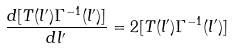Convert formula to latex. <formula><loc_0><loc_0><loc_500><loc_500>\frac { d [ T ( l ^ { \prime } ) \Gamma ^ { - 1 } ( l ^ { \prime } ) ] } { d l ^ { \prime } } = 2 [ T ( l ^ { \prime } ) \Gamma ^ { - 1 } ( l ^ { \prime } ) ]</formula> 